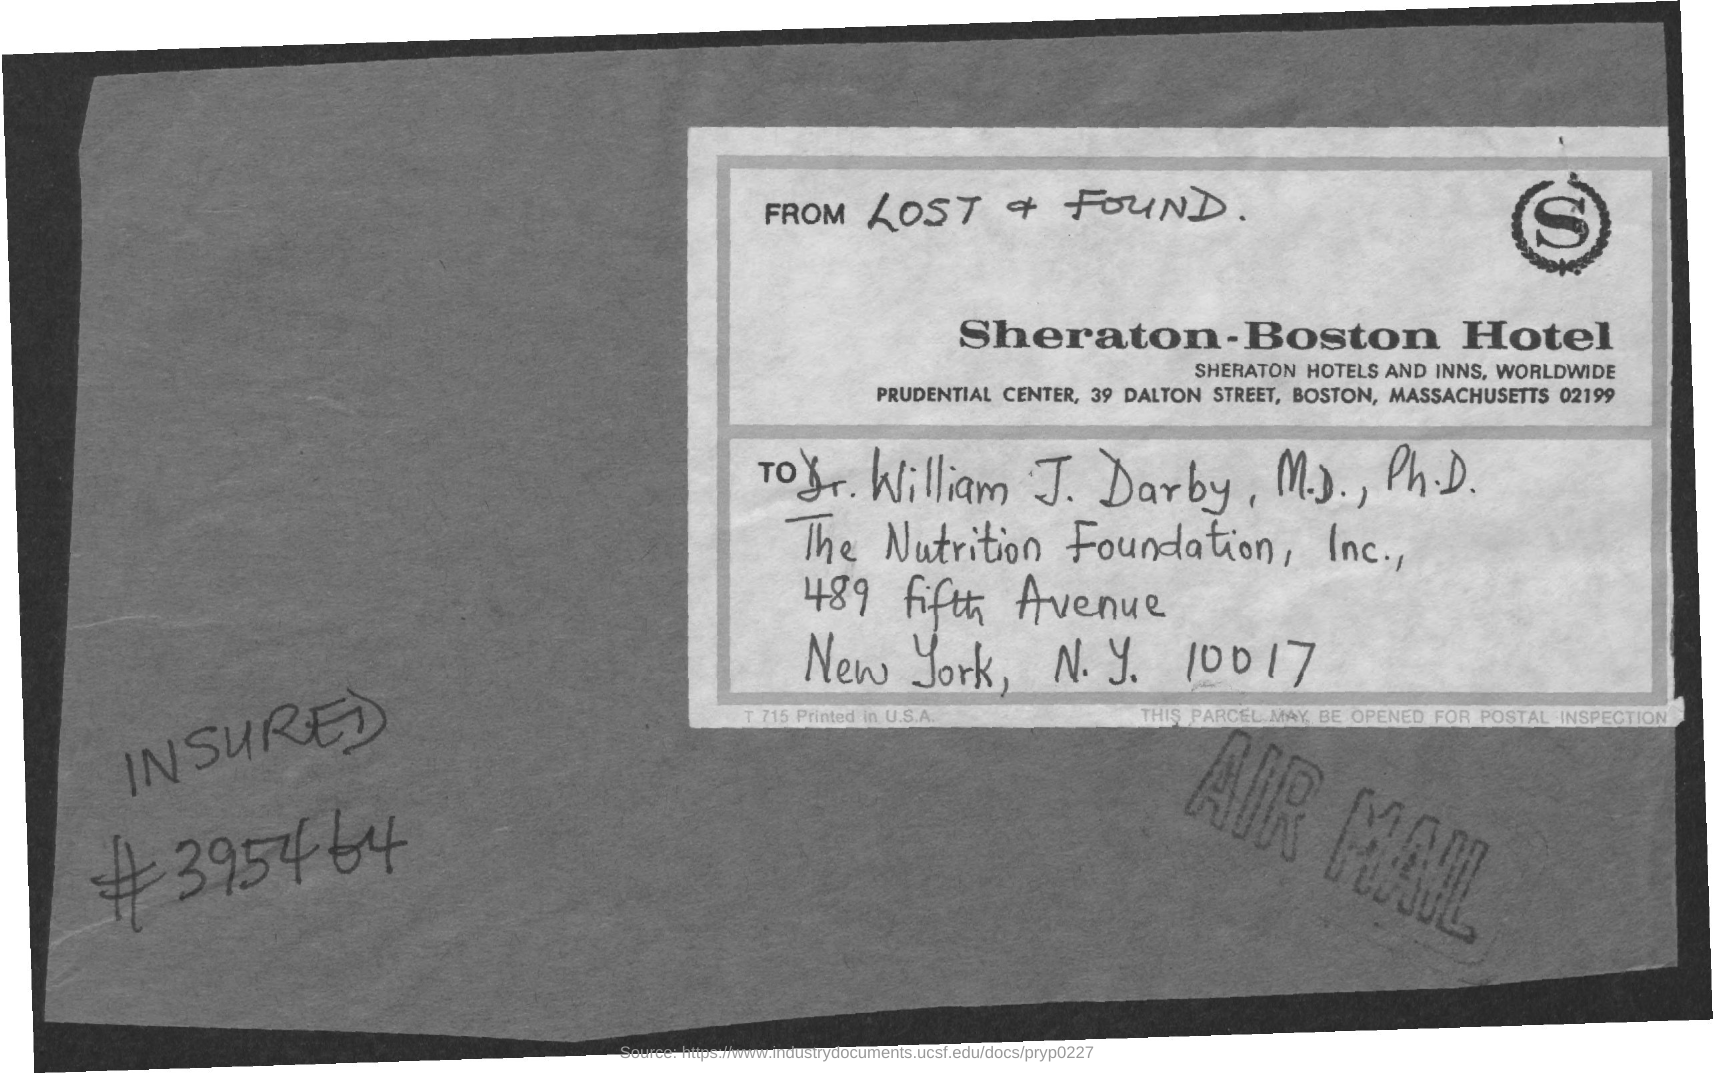What is the name of the Hotel?
Your answer should be very brief. Sheraton - Boston Hotel. Where is this letter from?
Give a very brief answer. Sheraton - Boston Hotel. What is the name of the person this addressed to?
Your answer should be very brief. Dr. William J. Darby , M.D. , Ph.D. What letter is written in the top-right logo?
Make the answer very short. S. 